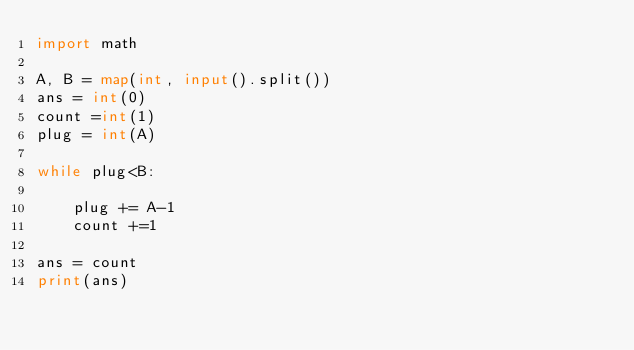<code> <loc_0><loc_0><loc_500><loc_500><_Python_>import math

A, B = map(int, input().split())
ans = int(0)
count =int(1)
plug = int(A)

while plug<B:

    plug += A-1
    count +=1

ans = count
print(ans)</code> 